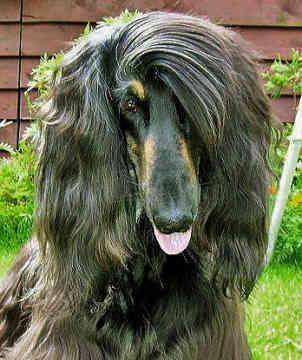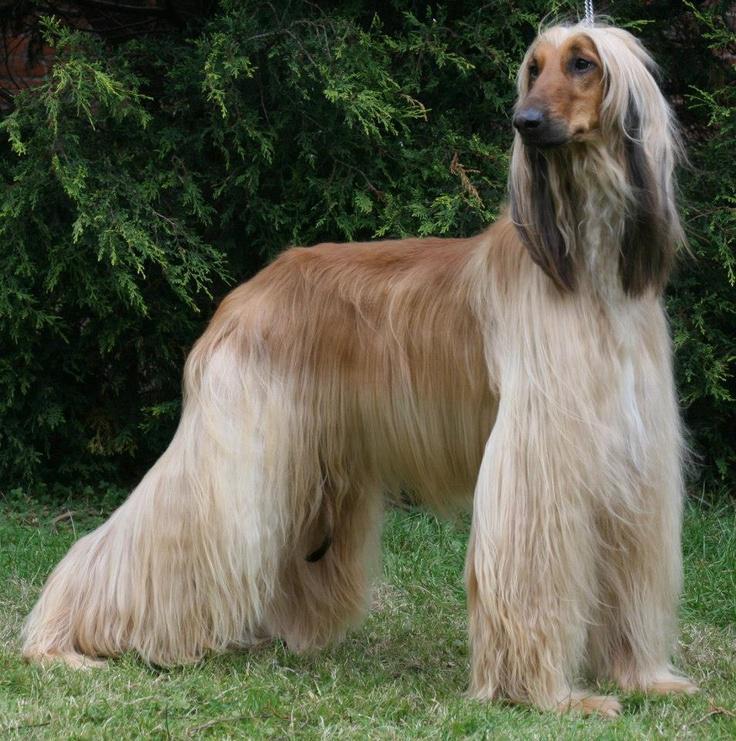The first image is the image on the left, the second image is the image on the right. Given the left and right images, does the statement "There are at least 2 dogs lying on the ground and facing right." hold true? Answer yes or no. No. 